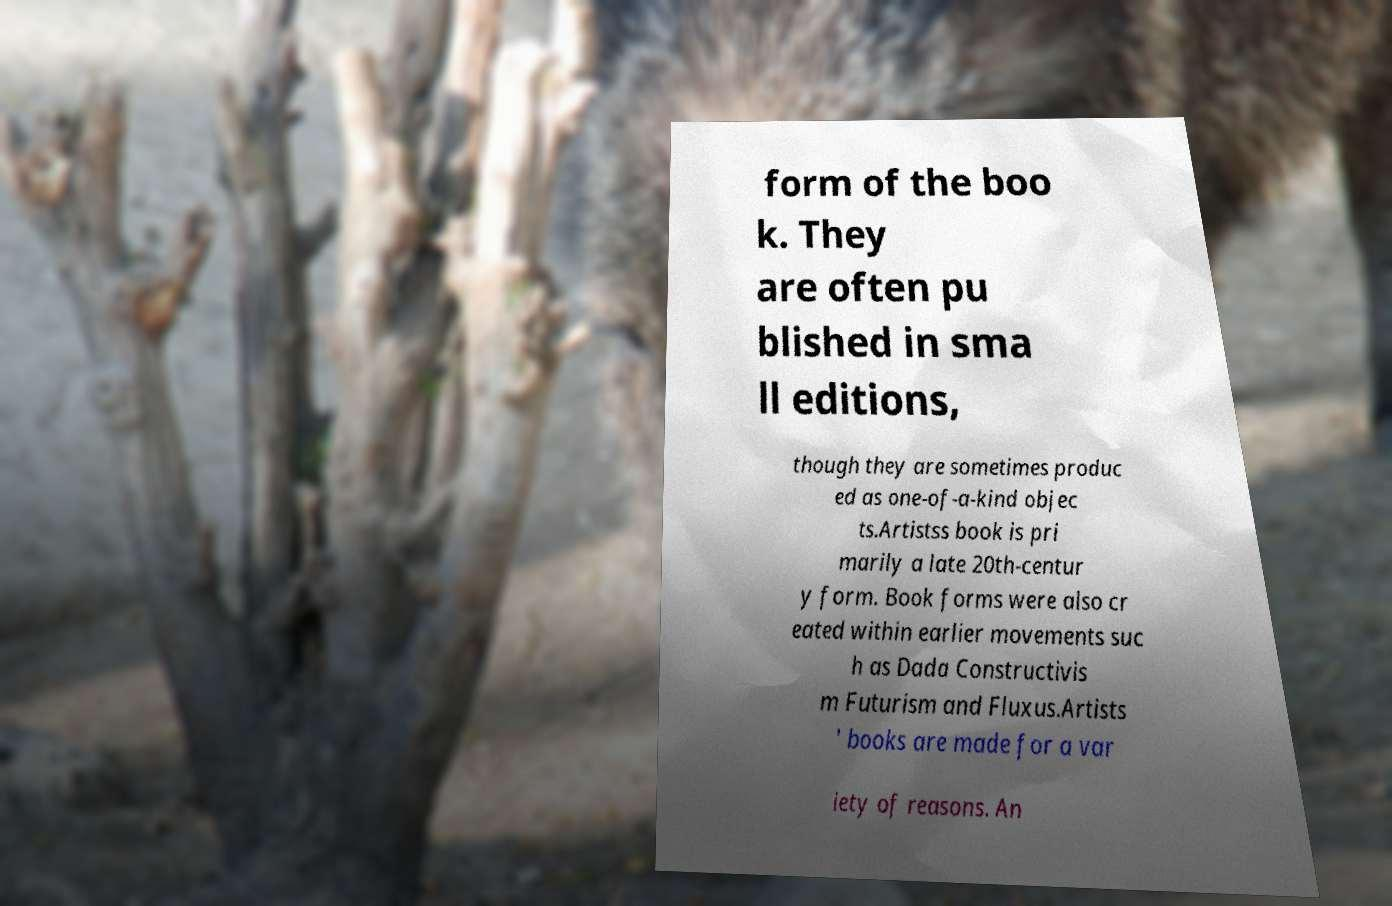Please identify and transcribe the text found in this image. form of the boo k. They are often pu blished in sma ll editions, though they are sometimes produc ed as one-of-a-kind objec ts.Artistss book is pri marily a late 20th-centur y form. Book forms were also cr eated within earlier movements suc h as Dada Constructivis m Futurism and Fluxus.Artists ' books are made for a var iety of reasons. An 